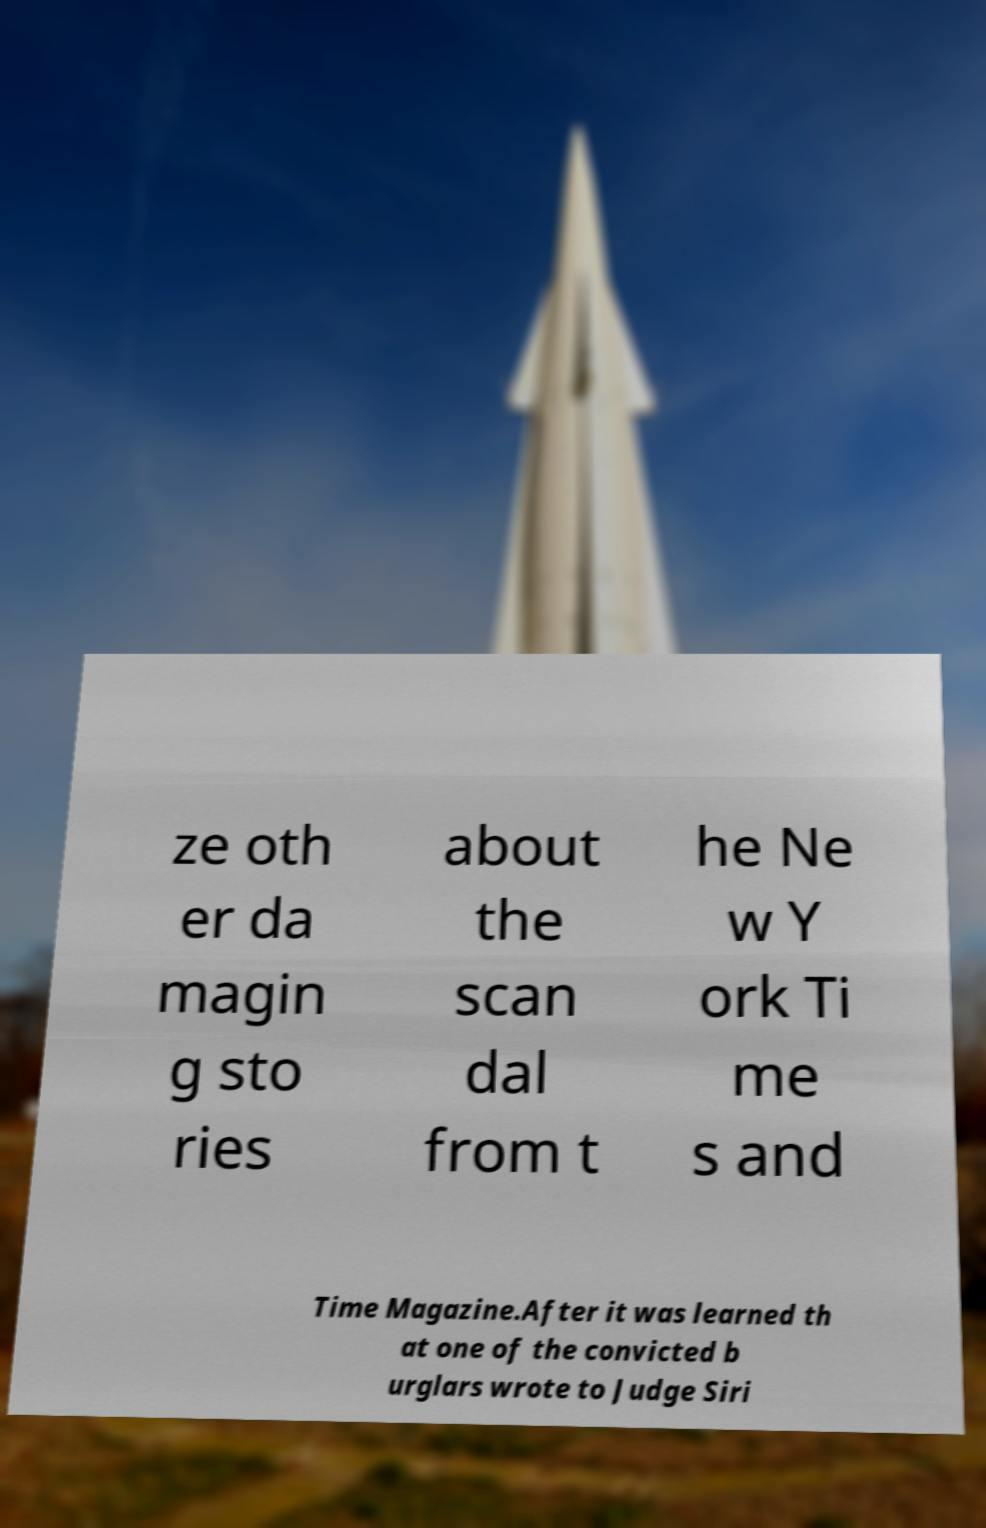Can you accurately transcribe the text from the provided image for me? ze oth er da magin g sto ries about the scan dal from t he Ne w Y ork Ti me s and Time Magazine.After it was learned th at one of the convicted b urglars wrote to Judge Siri 